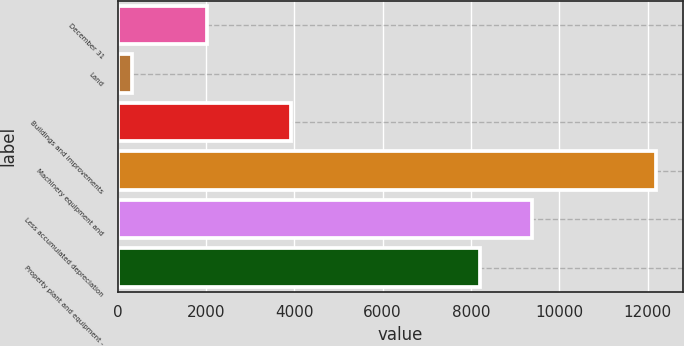Convert chart. <chart><loc_0><loc_0><loc_500><loc_500><bar_chart><fcel>December 31<fcel>Land<fcel>Buildings and improvements<fcel>Machinery equipment and<fcel>Less accumulated depreciation<fcel>Property plant and equipment -<nl><fcel>2017<fcel>334<fcel>3917<fcel>12198<fcel>9389.4<fcel>8203<nl></chart> 